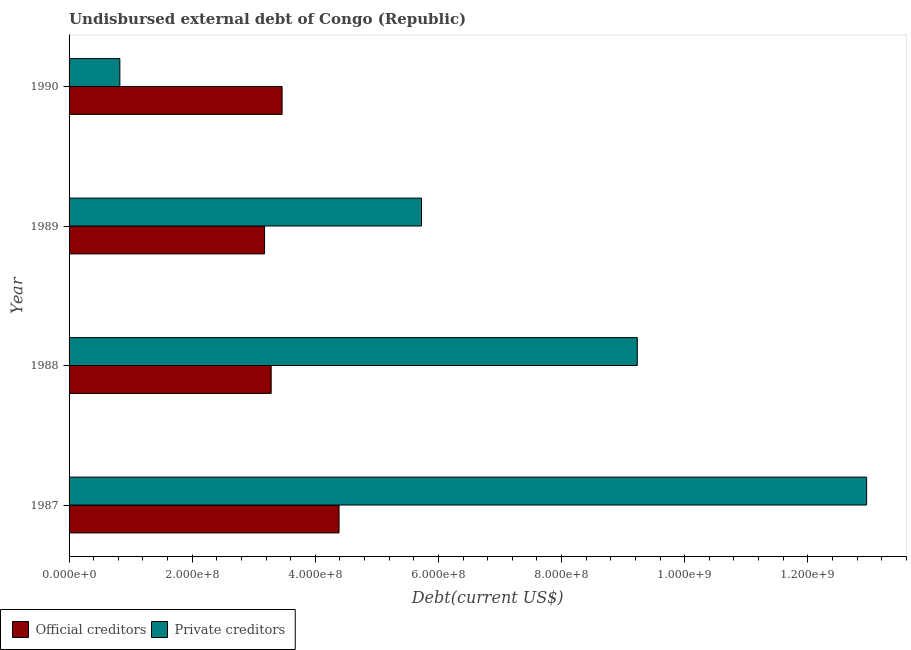How many different coloured bars are there?
Provide a short and direct response. 2. How many groups of bars are there?
Provide a short and direct response. 4. Are the number of bars per tick equal to the number of legend labels?
Your answer should be very brief. Yes. Are the number of bars on each tick of the Y-axis equal?
Offer a very short reply. Yes. What is the label of the 4th group of bars from the top?
Offer a terse response. 1987. What is the undisbursed external debt of official creditors in 1988?
Provide a succinct answer. 3.28e+08. Across all years, what is the maximum undisbursed external debt of private creditors?
Offer a very short reply. 1.30e+09. Across all years, what is the minimum undisbursed external debt of official creditors?
Give a very brief answer. 3.18e+08. What is the total undisbursed external debt of official creditors in the graph?
Offer a terse response. 1.43e+09. What is the difference between the undisbursed external debt of private creditors in 1988 and that in 1989?
Ensure brevity in your answer.  3.51e+08. What is the difference between the undisbursed external debt of official creditors in 1989 and the undisbursed external debt of private creditors in 1990?
Provide a succinct answer. 2.35e+08. What is the average undisbursed external debt of official creditors per year?
Offer a terse response. 3.58e+08. In the year 1990, what is the difference between the undisbursed external debt of official creditors and undisbursed external debt of private creditors?
Ensure brevity in your answer.  2.64e+08. What is the ratio of the undisbursed external debt of private creditors in 1988 to that in 1990?
Provide a short and direct response. 11.19. Is the undisbursed external debt of official creditors in 1989 less than that in 1990?
Give a very brief answer. Yes. What is the difference between the highest and the second highest undisbursed external debt of private creditors?
Provide a short and direct response. 3.72e+08. What is the difference between the highest and the lowest undisbursed external debt of private creditors?
Offer a very short reply. 1.21e+09. In how many years, is the undisbursed external debt of official creditors greater than the average undisbursed external debt of official creditors taken over all years?
Keep it short and to the point. 1. What does the 2nd bar from the top in 1988 represents?
Offer a very short reply. Official creditors. What does the 1st bar from the bottom in 1990 represents?
Keep it short and to the point. Official creditors. Are all the bars in the graph horizontal?
Your answer should be compact. Yes. How many years are there in the graph?
Ensure brevity in your answer.  4. What is the difference between two consecutive major ticks on the X-axis?
Ensure brevity in your answer.  2.00e+08. Are the values on the major ticks of X-axis written in scientific E-notation?
Your response must be concise. Yes. How many legend labels are there?
Ensure brevity in your answer.  2. How are the legend labels stacked?
Offer a very short reply. Horizontal. What is the title of the graph?
Give a very brief answer. Undisbursed external debt of Congo (Republic). What is the label or title of the X-axis?
Give a very brief answer. Debt(current US$). What is the label or title of the Y-axis?
Provide a succinct answer. Year. What is the Debt(current US$) in Official creditors in 1987?
Provide a succinct answer. 4.39e+08. What is the Debt(current US$) in Private creditors in 1987?
Make the answer very short. 1.30e+09. What is the Debt(current US$) of Official creditors in 1988?
Make the answer very short. 3.28e+08. What is the Debt(current US$) in Private creditors in 1988?
Offer a very short reply. 9.23e+08. What is the Debt(current US$) of Official creditors in 1989?
Your answer should be compact. 3.18e+08. What is the Debt(current US$) in Private creditors in 1989?
Provide a short and direct response. 5.72e+08. What is the Debt(current US$) in Official creditors in 1990?
Make the answer very short. 3.46e+08. What is the Debt(current US$) of Private creditors in 1990?
Provide a succinct answer. 8.25e+07. Across all years, what is the maximum Debt(current US$) in Official creditors?
Keep it short and to the point. 4.39e+08. Across all years, what is the maximum Debt(current US$) in Private creditors?
Keep it short and to the point. 1.30e+09. Across all years, what is the minimum Debt(current US$) in Official creditors?
Provide a succinct answer. 3.18e+08. Across all years, what is the minimum Debt(current US$) of Private creditors?
Provide a short and direct response. 8.25e+07. What is the total Debt(current US$) in Official creditors in the graph?
Provide a short and direct response. 1.43e+09. What is the total Debt(current US$) in Private creditors in the graph?
Offer a very short reply. 2.87e+09. What is the difference between the Debt(current US$) in Official creditors in 1987 and that in 1988?
Your answer should be compact. 1.10e+08. What is the difference between the Debt(current US$) of Private creditors in 1987 and that in 1988?
Offer a terse response. 3.72e+08. What is the difference between the Debt(current US$) in Official creditors in 1987 and that in 1989?
Give a very brief answer. 1.21e+08. What is the difference between the Debt(current US$) of Private creditors in 1987 and that in 1989?
Offer a terse response. 7.23e+08. What is the difference between the Debt(current US$) in Official creditors in 1987 and that in 1990?
Your response must be concise. 9.25e+07. What is the difference between the Debt(current US$) in Private creditors in 1987 and that in 1990?
Provide a succinct answer. 1.21e+09. What is the difference between the Debt(current US$) of Official creditors in 1988 and that in 1989?
Offer a very short reply. 1.07e+07. What is the difference between the Debt(current US$) of Private creditors in 1988 and that in 1989?
Offer a terse response. 3.51e+08. What is the difference between the Debt(current US$) of Official creditors in 1988 and that in 1990?
Give a very brief answer. -1.78e+07. What is the difference between the Debt(current US$) of Private creditors in 1988 and that in 1990?
Your answer should be very brief. 8.41e+08. What is the difference between the Debt(current US$) of Official creditors in 1989 and that in 1990?
Your answer should be very brief. -2.85e+07. What is the difference between the Debt(current US$) of Private creditors in 1989 and that in 1990?
Your response must be concise. 4.90e+08. What is the difference between the Debt(current US$) of Official creditors in 1987 and the Debt(current US$) of Private creditors in 1988?
Provide a succinct answer. -4.84e+08. What is the difference between the Debt(current US$) of Official creditors in 1987 and the Debt(current US$) of Private creditors in 1989?
Make the answer very short. -1.34e+08. What is the difference between the Debt(current US$) of Official creditors in 1987 and the Debt(current US$) of Private creditors in 1990?
Your response must be concise. 3.56e+08. What is the difference between the Debt(current US$) in Official creditors in 1988 and the Debt(current US$) in Private creditors in 1989?
Ensure brevity in your answer.  -2.44e+08. What is the difference between the Debt(current US$) in Official creditors in 1988 and the Debt(current US$) in Private creditors in 1990?
Your answer should be very brief. 2.46e+08. What is the difference between the Debt(current US$) in Official creditors in 1989 and the Debt(current US$) in Private creditors in 1990?
Your response must be concise. 2.35e+08. What is the average Debt(current US$) in Official creditors per year?
Offer a very short reply. 3.58e+08. What is the average Debt(current US$) in Private creditors per year?
Provide a short and direct response. 7.18e+08. In the year 1987, what is the difference between the Debt(current US$) in Official creditors and Debt(current US$) in Private creditors?
Provide a succinct answer. -8.57e+08. In the year 1988, what is the difference between the Debt(current US$) of Official creditors and Debt(current US$) of Private creditors?
Offer a terse response. -5.95e+08. In the year 1989, what is the difference between the Debt(current US$) in Official creditors and Debt(current US$) in Private creditors?
Provide a short and direct response. -2.55e+08. In the year 1990, what is the difference between the Debt(current US$) of Official creditors and Debt(current US$) of Private creditors?
Your answer should be very brief. 2.64e+08. What is the ratio of the Debt(current US$) of Official creditors in 1987 to that in 1988?
Make the answer very short. 1.34. What is the ratio of the Debt(current US$) of Private creditors in 1987 to that in 1988?
Make the answer very short. 1.4. What is the ratio of the Debt(current US$) of Official creditors in 1987 to that in 1989?
Provide a short and direct response. 1.38. What is the ratio of the Debt(current US$) of Private creditors in 1987 to that in 1989?
Your answer should be compact. 2.26. What is the ratio of the Debt(current US$) of Official creditors in 1987 to that in 1990?
Your answer should be compact. 1.27. What is the ratio of the Debt(current US$) in Private creditors in 1987 to that in 1990?
Your answer should be compact. 15.7. What is the ratio of the Debt(current US$) in Official creditors in 1988 to that in 1989?
Offer a terse response. 1.03. What is the ratio of the Debt(current US$) of Private creditors in 1988 to that in 1989?
Make the answer very short. 1.61. What is the ratio of the Debt(current US$) of Official creditors in 1988 to that in 1990?
Provide a succinct answer. 0.95. What is the ratio of the Debt(current US$) of Private creditors in 1988 to that in 1990?
Provide a succinct answer. 11.19. What is the ratio of the Debt(current US$) in Official creditors in 1989 to that in 1990?
Your answer should be compact. 0.92. What is the ratio of the Debt(current US$) of Private creditors in 1989 to that in 1990?
Your answer should be compact. 6.94. What is the difference between the highest and the second highest Debt(current US$) in Official creditors?
Your answer should be compact. 9.25e+07. What is the difference between the highest and the second highest Debt(current US$) of Private creditors?
Your response must be concise. 3.72e+08. What is the difference between the highest and the lowest Debt(current US$) in Official creditors?
Your response must be concise. 1.21e+08. What is the difference between the highest and the lowest Debt(current US$) in Private creditors?
Ensure brevity in your answer.  1.21e+09. 